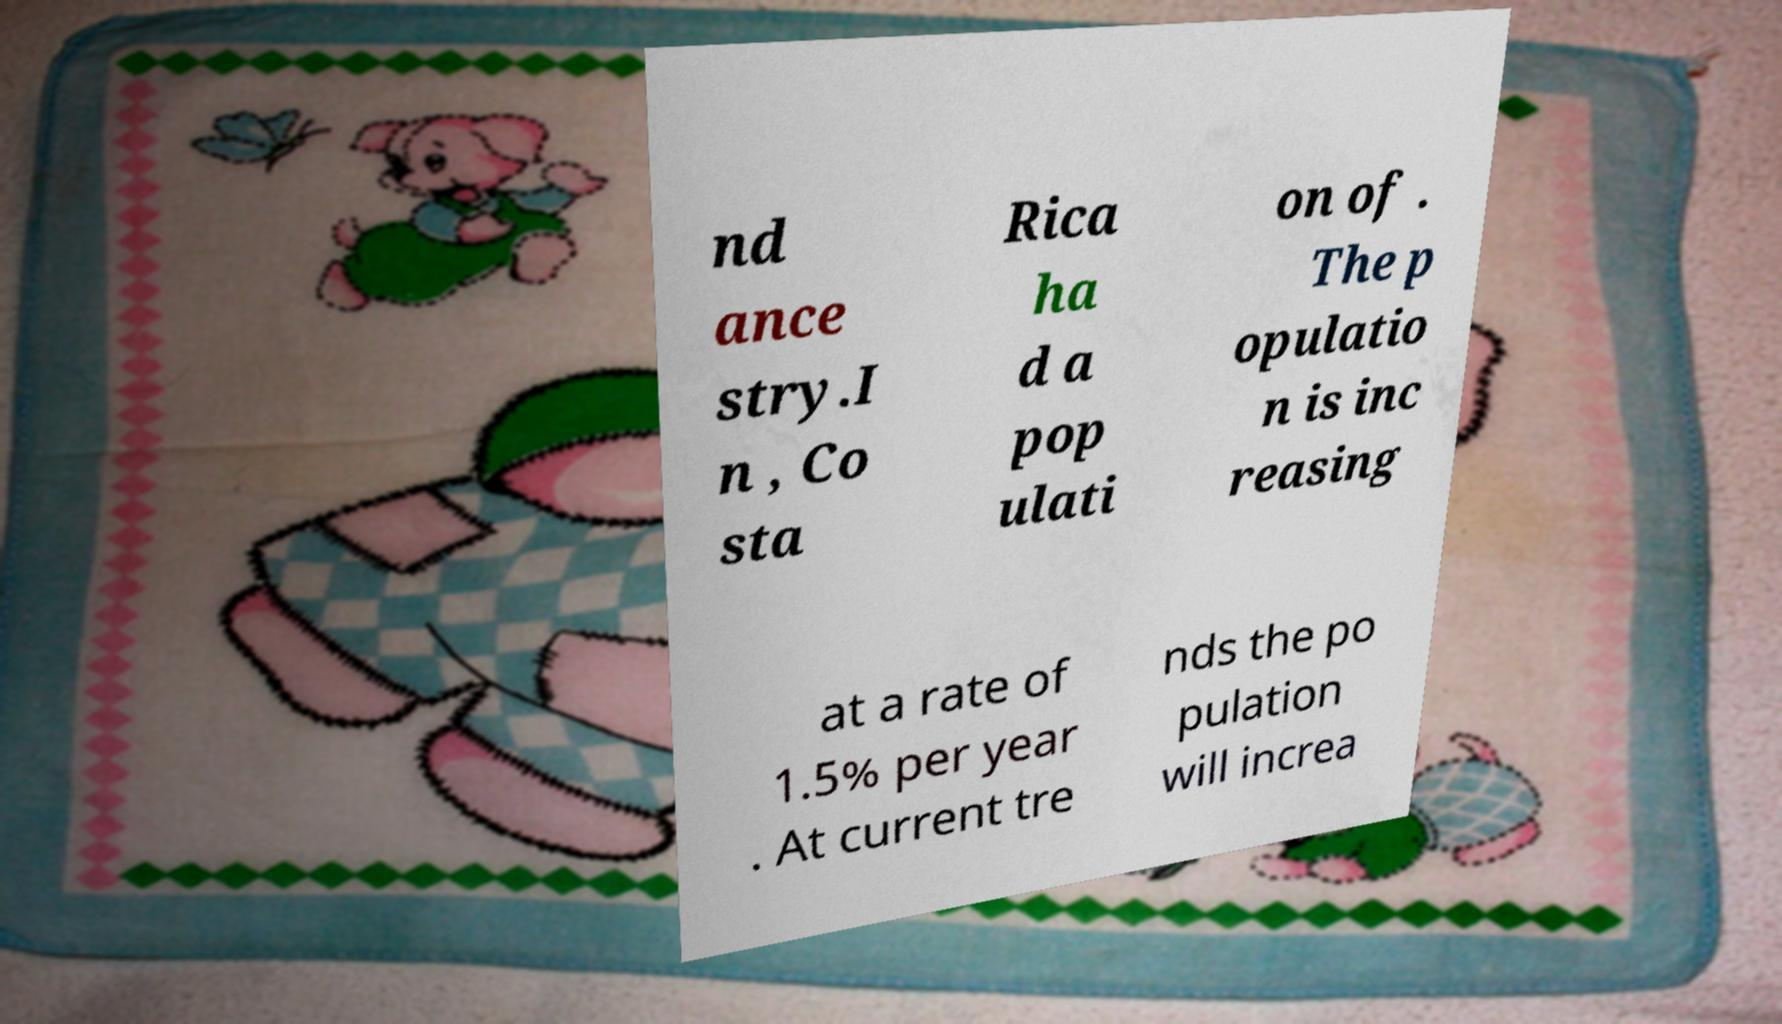Please identify and transcribe the text found in this image. nd ance stry.I n , Co sta Rica ha d a pop ulati on of . The p opulatio n is inc reasing at a rate of 1.5% per year . At current tre nds the po pulation will increa 